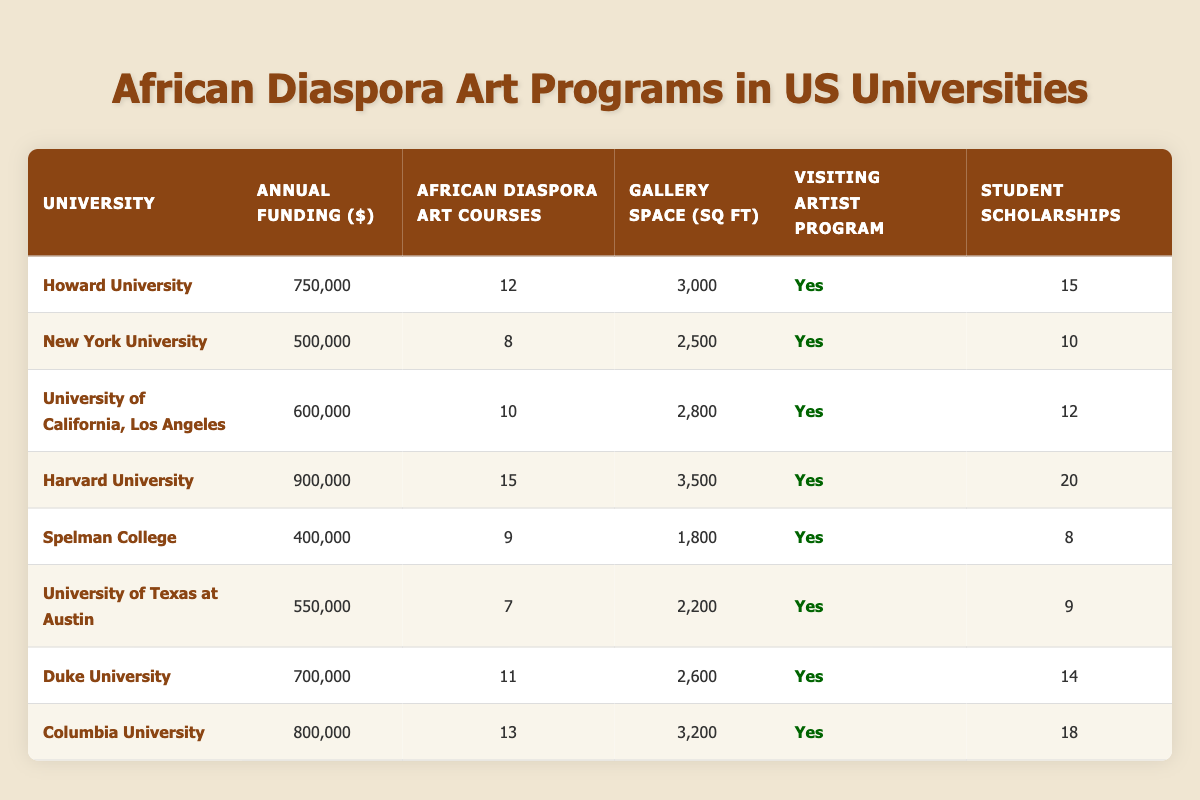What university has the highest annual funding for African Diaspora art programs? By reviewing the "Annual Funding ($)" column, Harvard University is listed at 900,000, which is higher than any other university in the table.
Answer: Harvard University How many African Diaspora art courses does the University of California, Los Angeles offer? The "Number of African Diaspora Art Courses" column indicates that UCLA offers 10 courses.
Answer: 10 What is the total amount of student scholarships offered by Duke University and Howard University combined? Adding the "Student Scholarships" for Duke University (14) and Howard University (15) gives a total of 14 + 15 = 29 scholarships combined.
Answer: 29 Which university provides the least dedicated gallery space for African Diaspora art? Looking at the "Dedicated Gallery Space (sq ft)" column, the smallest value is 1,800 sq ft, which corresponds to Spelman College.
Answer: Spelman College Is there a visiting artist program at the University of Texas at Austin? Checking the "Visiting Artist Program" column, it shows "Yes" for the University of Texas at Austin, confirming the existence of such a program.
Answer: Yes What is the average annual funding across all universities listed in the table? To find the average, sum up the annual funding for all universities: 750,000 + 500,000 + 600,000 + 900,000 + 400,000 + 550,000 + 700,000 + 800,000 = 4,250,000. There are 8 universities, so the average is 4,250,000 / 8 = 531,250.
Answer: 531,250 What university has the most African Diaspora art courses, and how many does it offer? Reviewing the "Number of African Diaspora Art Courses" column, Harvard University has 15 courses, which is the highest number among all listed universities.
Answer: Harvard University, 15 courses How many universities have an annual funding greater than 600,000? From the "Annual Funding ($)" column, there are four universities (Harvard, Columbia, Howard, and Duke) with funding amounts above 600,000, confirming that 4 universities exceed this threshold.
Answer: 4 Is the dedicated gallery space of New York University greater than that of Spelman College? Comparing the values in the "Dedicated Gallery Space (sq ft)" column, NYU has 2,500 sq ft while Spelman College has 1,800 sq ft, meaning NYU's space is indeed greater.
Answer: Yes 